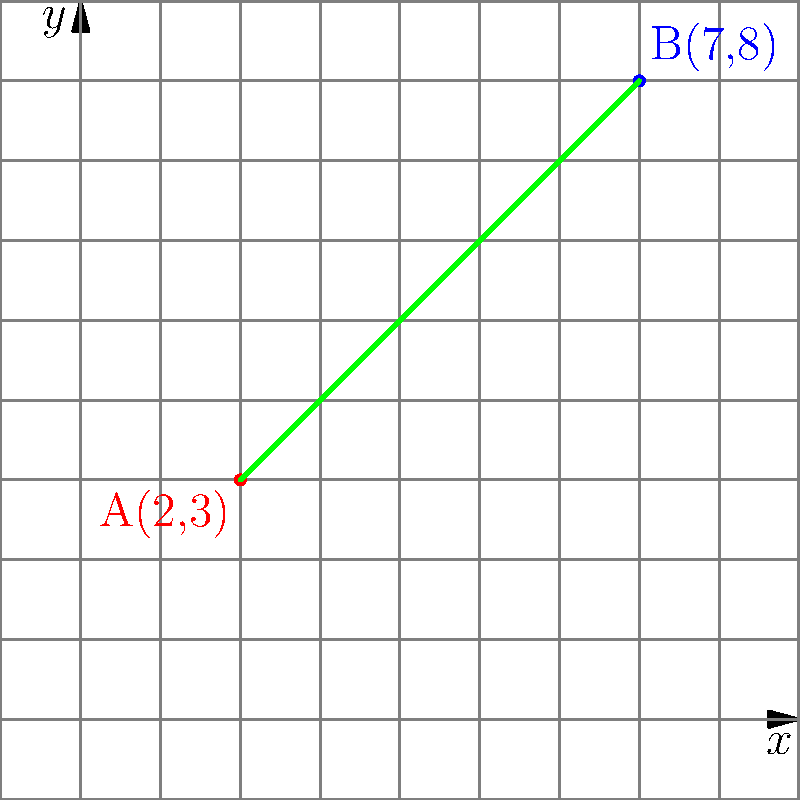In our ancestral lands, two sacred sites are marked on a map using a coordinate system. Site A is located at (2, 3) and site B is at (7, 8). As the keeper of our traditions, you need to determine the straight-line distance between these two sites to plan a ceremonial journey. Using the wisdom of our forefathers and the knowledge of the land, calculate the distance between points A and B. To find the distance between two points, we use the distance formula, which is derived from the Pythagorean theorem. Our ancestors understood the relationship between the sides of a right triangle, and we can apply this wisdom to our modern coordinate system.

1. Recall the distance formula:
   $$d = \sqrt{(x_2 - x_1)^2 + (y_2 - y_1)^2}$$

2. Identify the coordinates:
   Point A: $(x_1, y_1) = (2, 3)$
   Point B: $(x_2, y_2) = (7, 8)$

3. Substitute the values into the formula:
   $$d = \sqrt{(7 - 2)^2 + (8 - 3)^2}$$

4. Simplify the expressions inside the parentheses:
   $$d = \sqrt{5^2 + 5^2}$$

5. Calculate the squares:
   $$d = \sqrt{25 + 25}$$

6. Add the values under the square root:
   $$d = \sqrt{50}$$

7. Simplify the square root:
   $$d = 5\sqrt{2}$$

This result, $5\sqrt{2}$, represents the distance between the two sacred sites in the units used by our coordinate system.
Answer: $5\sqrt{2}$ units 